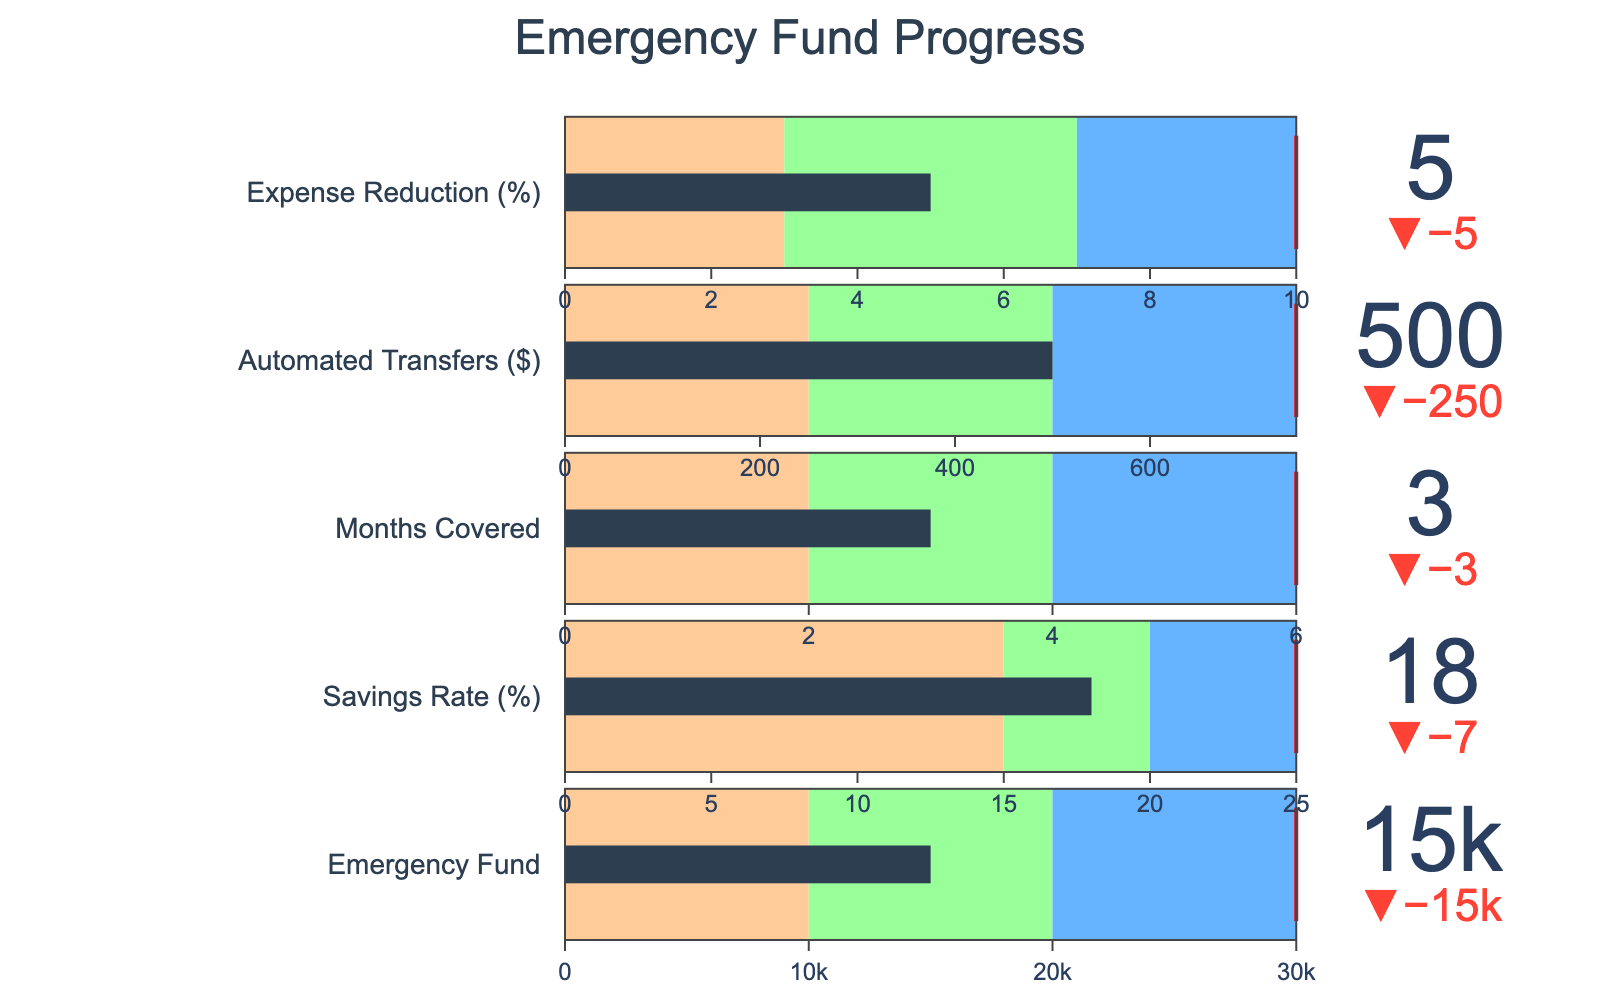What is the actual value for the Emergency Fund? The actual value for the Emergency Fund is given directly in the data under the "Actual" column. It is 15,000.
Answer: 15,000 How much more money is needed to reach the target for the Emergency Fund? The target amount for the Emergency Fund is 30,000, and the actual amount is 15,000. The difference is 30,000 - 15,000 = 15,000.
Answer: 15,000 Which category shows the highest actual value percentage of the target achieved? To find this, we need to calculate the percentage of the target achieved for each category and compare them. Emergency Fund: (15,000 / 30,000) * 100 = 50%, Savings Rate: (18 / 25) * 100 = 72%, Months Covered: (3 / 6) * 100 = 50%, Automated Transfers: (500 / 750) * 100 = 66.67%, Expense Reduction: (5 / 10) * 100 = 50%. The highest percentage is for the Savings Rate.
Answer: Savings Rate How close is the Automated Transfers category to reaching the "Good" range? For Automated Transfers, the "Good" range starts at 500 and goes up to 750. The actual value is 500, which is at the beginning of the "Good" range. Therefore, it has just reached the "Good" range.
Answer: At the start of "Good" range How many months will twelve Automated Transfers of $500 each cover? Each Automated Transfer is $500, so twelve Automated Transfers amount to 500 * 12 = 6,000. If monthly expenses are 5,000 (since 30,000/6 = 5,000), then 6,000 / 5,000 = 1.2 months.
Answer: 1.2 months Is any category already in the "Very Good" range? To determine this, we look at the actual values compared to the "Very Good" thresholds. Emergency Fund: 15,000 < 30,000; Savings Rate: 18 < 25; Months Covered: 3 < 6; Automated Transfers: 500 < 750; Expense Reduction: 5 < 10. None of the categories are in the "Very Good" range.
Answer: No 